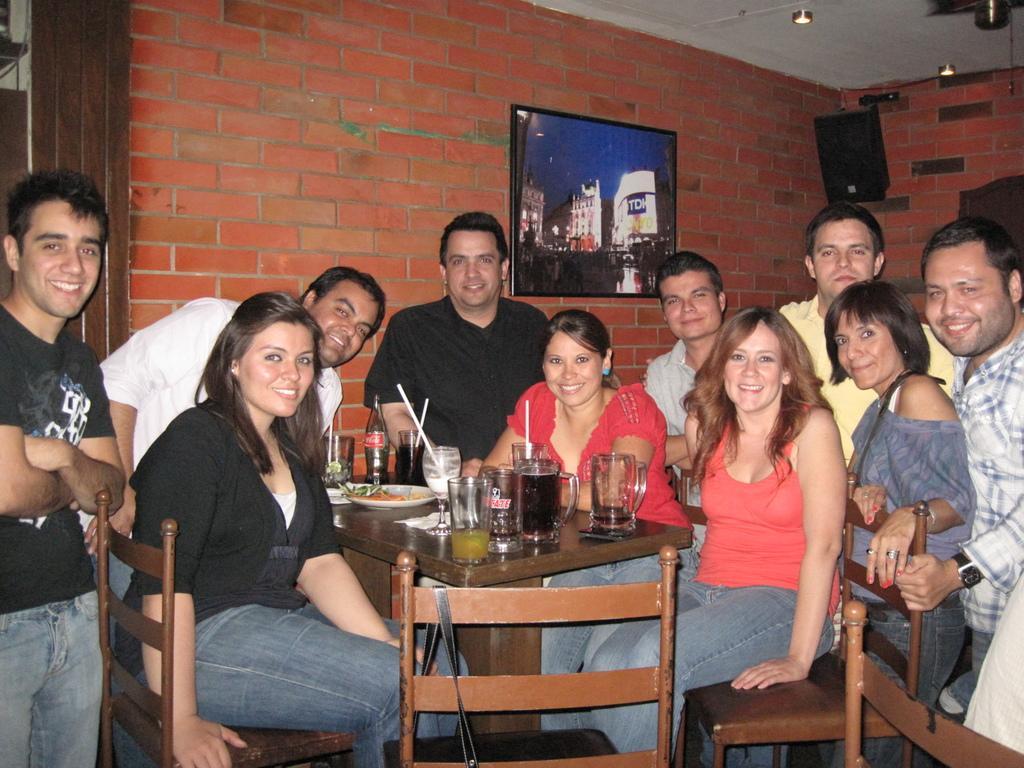Describe this image in one or two sentences. A group of people inside this room. This 3 persons are sitting on a chair. On table there are glasses, plate and bottle. A picture is attached to this brick wall. On the top there is a sound box. 